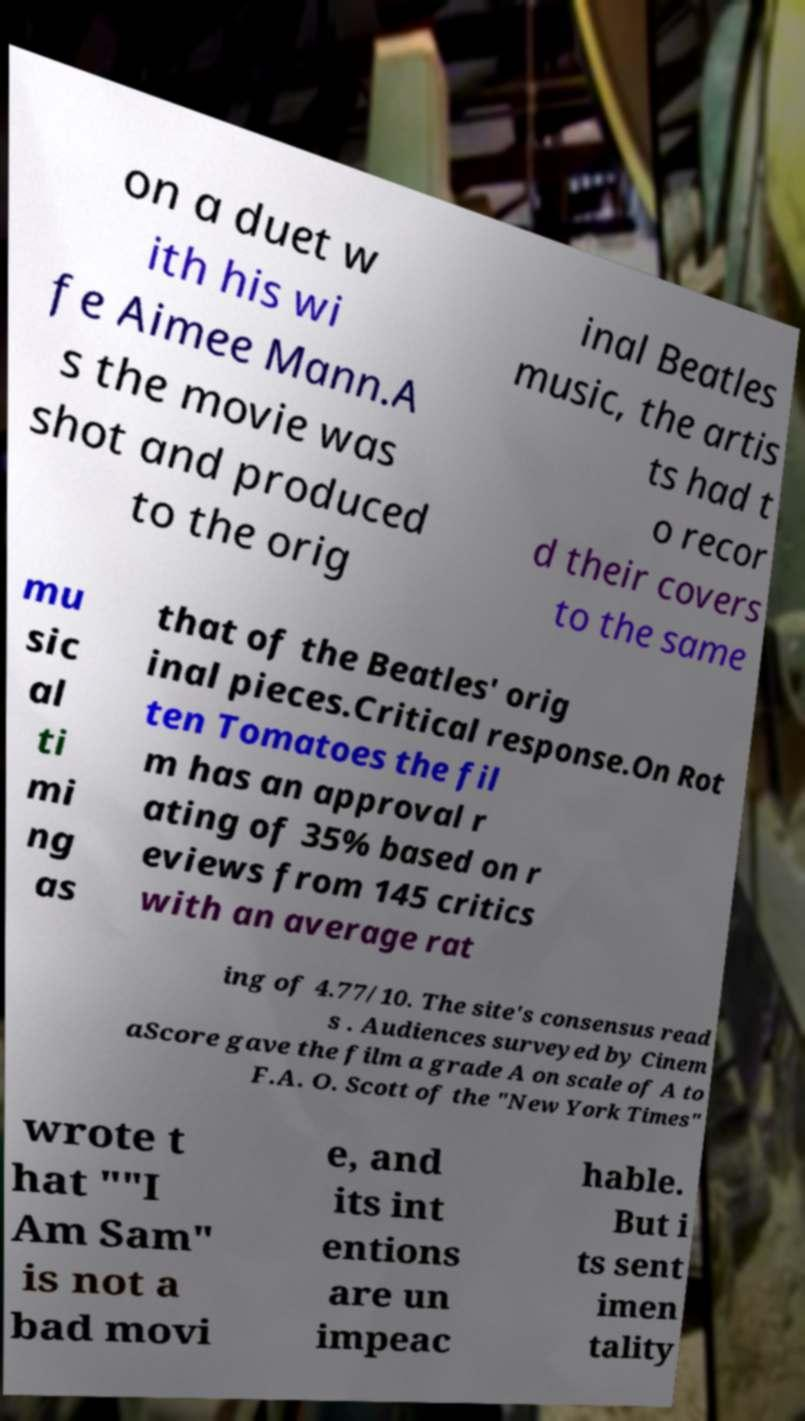Can you accurately transcribe the text from the provided image for me? on a duet w ith his wi fe Aimee Mann.A s the movie was shot and produced to the orig inal Beatles music, the artis ts had t o recor d their covers to the same mu sic al ti mi ng as that of the Beatles' orig inal pieces.Critical response.On Rot ten Tomatoes the fil m has an approval r ating of 35% based on r eviews from 145 critics with an average rat ing of 4.77/10. The site's consensus read s . Audiences surveyed by Cinem aScore gave the film a grade A on scale of A to F.A. O. Scott of the "New York Times" wrote t hat ""I Am Sam" is not a bad movi e, and its int entions are un impeac hable. But i ts sent imen tality 